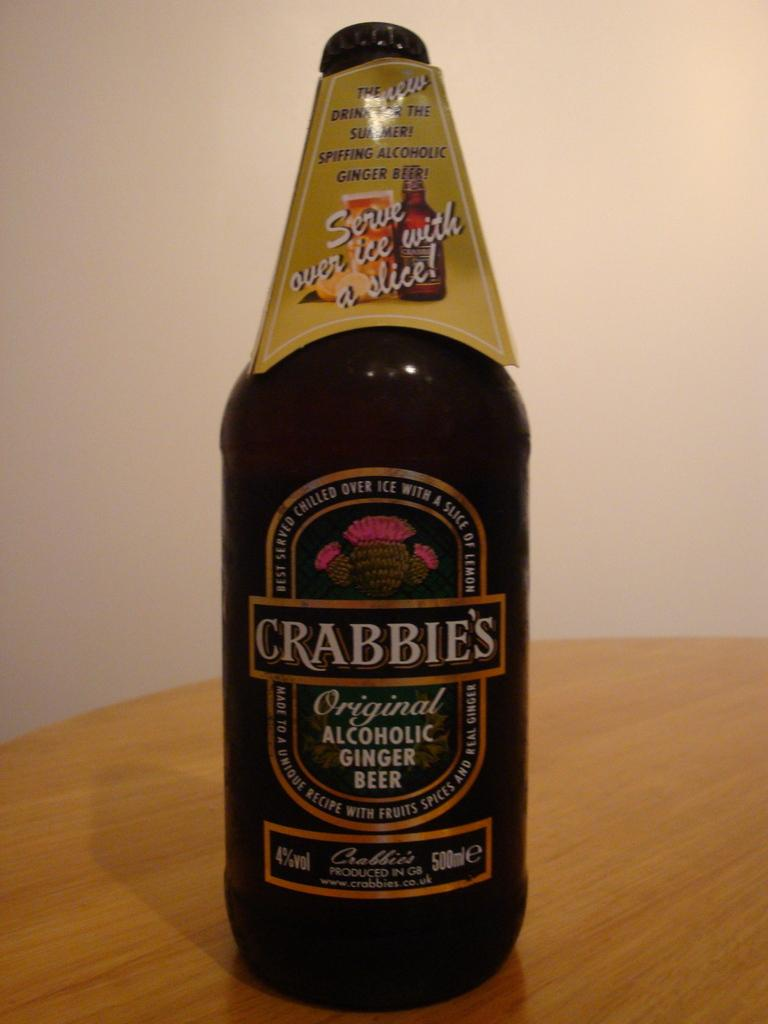Provide a one-sentence caption for the provided image. Bottle of Crabbies Original Alcholic Ginger Beer drink on a table. 